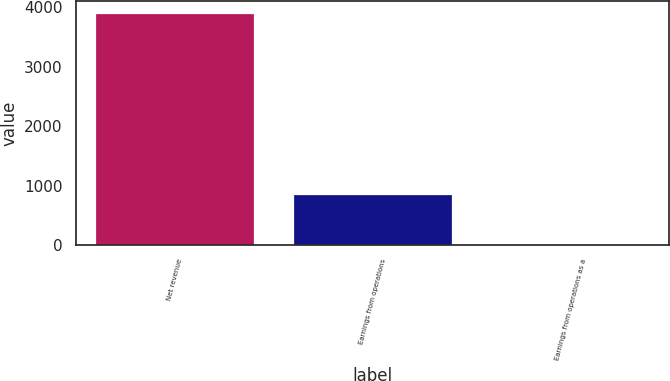Convert chart to OTSL. <chart><loc_0><loc_0><loc_500><loc_500><bar_chart><fcel>Net revenue<fcel>Earnings from operations<fcel>Earnings from operations as a<nl><fcel>3913<fcel>866<fcel>22.1<nl></chart> 